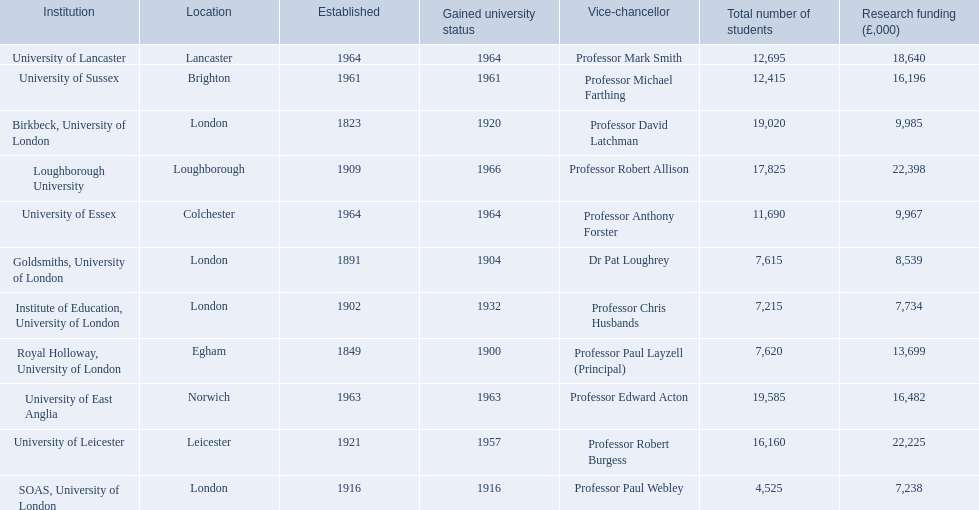What are the institutions in the 1994 group? Birkbeck, University of London, University of East Anglia, University of Essex, Goldsmiths, University of London, Institute of Education, University of London, University of Lancaster, University of Leicester, Loughborough University, Royal Holloway, University of London, SOAS, University of London, University of Sussex. Which of these was made a university most recently? Loughborough University. 